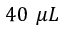<formula> <loc_0><loc_0><loc_500><loc_500>4 0 \mu L</formula> 